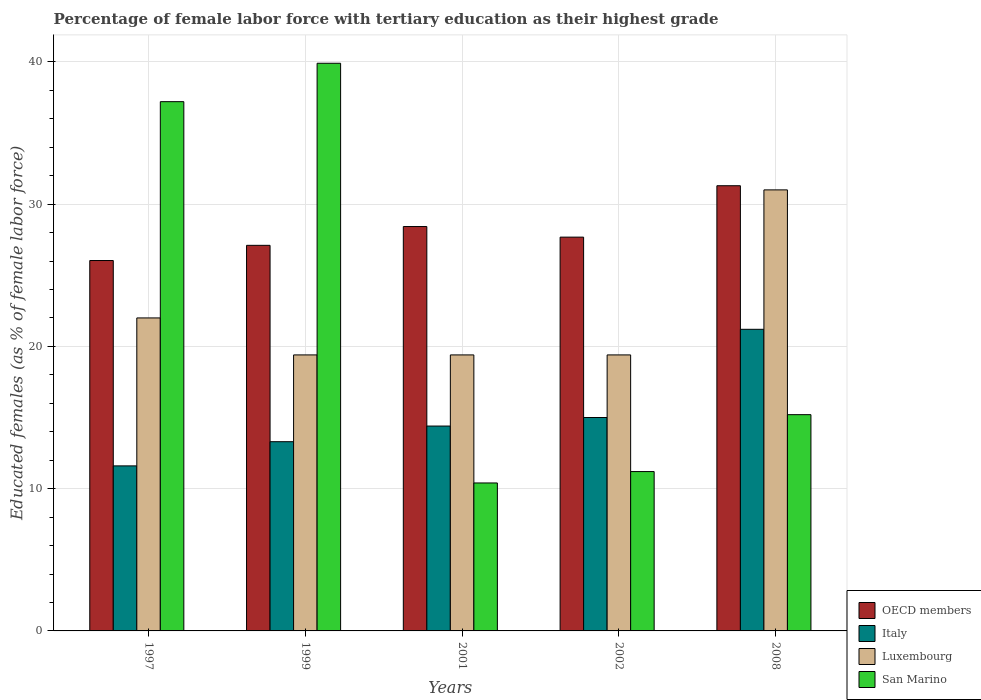How many groups of bars are there?
Provide a succinct answer. 5. Are the number of bars per tick equal to the number of legend labels?
Your answer should be very brief. Yes. Are the number of bars on each tick of the X-axis equal?
Provide a short and direct response. Yes. How many bars are there on the 4th tick from the right?
Offer a very short reply. 4. What is the label of the 5th group of bars from the left?
Offer a terse response. 2008. What is the percentage of female labor force with tertiary education in Italy in 2008?
Provide a short and direct response. 21.2. Across all years, what is the maximum percentage of female labor force with tertiary education in Italy?
Make the answer very short. 21.2. Across all years, what is the minimum percentage of female labor force with tertiary education in Italy?
Make the answer very short. 11.6. In which year was the percentage of female labor force with tertiary education in San Marino minimum?
Your answer should be compact. 2001. What is the total percentage of female labor force with tertiary education in Italy in the graph?
Keep it short and to the point. 75.5. What is the difference between the percentage of female labor force with tertiary education in OECD members in 1997 and that in 2008?
Ensure brevity in your answer.  -5.26. What is the difference between the percentage of female labor force with tertiary education in San Marino in 2002 and the percentage of female labor force with tertiary education in Luxembourg in 1999?
Make the answer very short. -8.2. What is the average percentage of female labor force with tertiary education in San Marino per year?
Your answer should be compact. 22.78. In the year 2001, what is the difference between the percentage of female labor force with tertiary education in Luxembourg and percentage of female labor force with tertiary education in OECD members?
Keep it short and to the point. -9.02. What is the ratio of the percentage of female labor force with tertiary education in OECD members in 2002 to that in 2008?
Give a very brief answer. 0.88. Is the percentage of female labor force with tertiary education in San Marino in 1997 less than that in 2001?
Provide a succinct answer. No. What is the difference between the highest and the second highest percentage of female labor force with tertiary education in OECD members?
Keep it short and to the point. 2.87. What is the difference between the highest and the lowest percentage of female labor force with tertiary education in San Marino?
Offer a very short reply. 29.5. Is the sum of the percentage of female labor force with tertiary education in Luxembourg in 2001 and 2008 greater than the maximum percentage of female labor force with tertiary education in San Marino across all years?
Your response must be concise. Yes. What does the 1st bar from the left in 2001 represents?
Offer a very short reply. OECD members. What does the 2nd bar from the right in 2001 represents?
Your answer should be very brief. Luxembourg. Is it the case that in every year, the sum of the percentage of female labor force with tertiary education in Italy and percentage of female labor force with tertiary education in San Marino is greater than the percentage of female labor force with tertiary education in Luxembourg?
Keep it short and to the point. Yes. Does the graph contain any zero values?
Provide a short and direct response. No. Does the graph contain grids?
Your response must be concise. Yes. What is the title of the graph?
Keep it short and to the point. Percentage of female labor force with tertiary education as their highest grade. Does "Ecuador" appear as one of the legend labels in the graph?
Offer a very short reply. No. What is the label or title of the Y-axis?
Provide a succinct answer. Educated females (as % of female labor force). What is the Educated females (as % of female labor force) in OECD members in 1997?
Your answer should be compact. 26.03. What is the Educated females (as % of female labor force) in Italy in 1997?
Make the answer very short. 11.6. What is the Educated females (as % of female labor force) in San Marino in 1997?
Offer a terse response. 37.2. What is the Educated females (as % of female labor force) in OECD members in 1999?
Ensure brevity in your answer.  27.1. What is the Educated females (as % of female labor force) of Italy in 1999?
Provide a short and direct response. 13.3. What is the Educated females (as % of female labor force) in Luxembourg in 1999?
Give a very brief answer. 19.4. What is the Educated females (as % of female labor force) of San Marino in 1999?
Ensure brevity in your answer.  39.9. What is the Educated females (as % of female labor force) in OECD members in 2001?
Your answer should be very brief. 28.42. What is the Educated females (as % of female labor force) of Italy in 2001?
Your answer should be compact. 14.4. What is the Educated females (as % of female labor force) of Luxembourg in 2001?
Provide a succinct answer. 19.4. What is the Educated females (as % of female labor force) of San Marino in 2001?
Offer a terse response. 10.4. What is the Educated females (as % of female labor force) in OECD members in 2002?
Provide a succinct answer. 27.68. What is the Educated females (as % of female labor force) in Luxembourg in 2002?
Provide a succinct answer. 19.4. What is the Educated females (as % of female labor force) in San Marino in 2002?
Provide a succinct answer. 11.2. What is the Educated females (as % of female labor force) in OECD members in 2008?
Provide a succinct answer. 31.29. What is the Educated females (as % of female labor force) in Italy in 2008?
Your answer should be very brief. 21.2. What is the Educated females (as % of female labor force) in Luxembourg in 2008?
Make the answer very short. 31. What is the Educated females (as % of female labor force) of San Marino in 2008?
Ensure brevity in your answer.  15.2. Across all years, what is the maximum Educated females (as % of female labor force) of OECD members?
Make the answer very short. 31.29. Across all years, what is the maximum Educated females (as % of female labor force) in Italy?
Your answer should be compact. 21.2. Across all years, what is the maximum Educated females (as % of female labor force) of San Marino?
Keep it short and to the point. 39.9. Across all years, what is the minimum Educated females (as % of female labor force) in OECD members?
Ensure brevity in your answer.  26.03. Across all years, what is the minimum Educated females (as % of female labor force) of Italy?
Make the answer very short. 11.6. Across all years, what is the minimum Educated females (as % of female labor force) in Luxembourg?
Offer a terse response. 19.4. Across all years, what is the minimum Educated females (as % of female labor force) of San Marino?
Keep it short and to the point. 10.4. What is the total Educated females (as % of female labor force) in OECD members in the graph?
Provide a short and direct response. 140.53. What is the total Educated females (as % of female labor force) in Italy in the graph?
Offer a terse response. 75.5. What is the total Educated females (as % of female labor force) of Luxembourg in the graph?
Offer a terse response. 111.2. What is the total Educated females (as % of female labor force) in San Marino in the graph?
Your answer should be compact. 113.9. What is the difference between the Educated females (as % of female labor force) of OECD members in 1997 and that in 1999?
Offer a terse response. -1.07. What is the difference between the Educated females (as % of female labor force) in Italy in 1997 and that in 1999?
Give a very brief answer. -1.7. What is the difference between the Educated females (as % of female labor force) of OECD members in 1997 and that in 2001?
Provide a short and direct response. -2.39. What is the difference between the Educated females (as % of female labor force) in Italy in 1997 and that in 2001?
Make the answer very short. -2.8. What is the difference between the Educated females (as % of female labor force) of San Marino in 1997 and that in 2001?
Provide a succinct answer. 26.8. What is the difference between the Educated females (as % of female labor force) in OECD members in 1997 and that in 2002?
Make the answer very short. -1.64. What is the difference between the Educated females (as % of female labor force) of Italy in 1997 and that in 2002?
Offer a very short reply. -3.4. What is the difference between the Educated females (as % of female labor force) of Luxembourg in 1997 and that in 2002?
Provide a succinct answer. 2.6. What is the difference between the Educated females (as % of female labor force) of OECD members in 1997 and that in 2008?
Your answer should be compact. -5.26. What is the difference between the Educated females (as % of female labor force) in Italy in 1997 and that in 2008?
Your response must be concise. -9.6. What is the difference between the Educated females (as % of female labor force) in Luxembourg in 1997 and that in 2008?
Offer a very short reply. -9. What is the difference between the Educated females (as % of female labor force) in OECD members in 1999 and that in 2001?
Ensure brevity in your answer.  -1.32. What is the difference between the Educated females (as % of female labor force) of Italy in 1999 and that in 2001?
Offer a terse response. -1.1. What is the difference between the Educated females (as % of female labor force) of Luxembourg in 1999 and that in 2001?
Ensure brevity in your answer.  0. What is the difference between the Educated females (as % of female labor force) of San Marino in 1999 and that in 2001?
Provide a short and direct response. 29.5. What is the difference between the Educated females (as % of female labor force) of OECD members in 1999 and that in 2002?
Your response must be concise. -0.58. What is the difference between the Educated females (as % of female labor force) of San Marino in 1999 and that in 2002?
Offer a very short reply. 28.7. What is the difference between the Educated females (as % of female labor force) in OECD members in 1999 and that in 2008?
Offer a very short reply. -4.19. What is the difference between the Educated females (as % of female labor force) of Italy in 1999 and that in 2008?
Give a very brief answer. -7.9. What is the difference between the Educated females (as % of female labor force) in San Marino in 1999 and that in 2008?
Give a very brief answer. 24.7. What is the difference between the Educated females (as % of female labor force) in OECD members in 2001 and that in 2002?
Provide a short and direct response. 0.74. What is the difference between the Educated females (as % of female labor force) of OECD members in 2001 and that in 2008?
Your answer should be very brief. -2.87. What is the difference between the Educated females (as % of female labor force) of OECD members in 2002 and that in 2008?
Offer a terse response. -3.61. What is the difference between the Educated females (as % of female labor force) of Luxembourg in 2002 and that in 2008?
Your response must be concise. -11.6. What is the difference between the Educated females (as % of female labor force) in OECD members in 1997 and the Educated females (as % of female labor force) in Italy in 1999?
Keep it short and to the point. 12.73. What is the difference between the Educated females (as % of female labor force) in OECD members in 1997 and the Educated females (as % of female labor force) in Luxembourg in 1999?
Provide a short and direct response. 6.63. What is the difference between the Educated females (as % of female labor force) in OECD members in 1997 and the Educated females (as % of female labor force) in San Marino in 1999?
Your answer should be compact. -13.87. What is the difference between the Educated females (as % of female labor force) in Italy in 1997 and the Educated females (as % of female labor force) in Luxembourg in 1999?
Provide a short and direct response. -7.8. What is the difference between the Educated females (as % of female labor force) of Italy in 1997 and the Educated females (as % of female labor force) of San Marino in 1999?
Provide a short and direct response. -28.3. What is the difference between the Educated females (as % of female labor force) of Luxembourg in 1997 and the Educated females (as % of female labor force) of San Marino in 1999?
Offer a very short reply. -17.9. What is the difference between the Educated females (as % of female labor force) of OECD members in 1997 and the Educated females (as % of female labor force) of Italy in 2001?
Give a very brief answer. 11.63. What is the difference between the Educated females (as % of female labor force) in OECD members in 1997 and the Educated females (as % of female labor force) in Luxembourg in 2001?
Make the answer very short. 6.63. What is the difference between the Educated females (as % of female labor force) of OECD members in 1997 and the Educated females (as % of female labor force) of San Marino in 2001?
Give a very brief answer. 15.63. What is the difference between the Educated females (as % of female labor force) of Italy in 1997 and the Educated females (as % of female labor force) of Luxembourg in 2001?
Your response must be concise. -7.8. What is the difference between the Educated females (as % of female labor force) in Italy in 1997 and the Educated females (as % of female labor force) in San Marino in 2001?
Offer a very short reply. 1.2. What is the difference between the Educated females (as % of female labor force) in OECD members in 1997 and the Educated females (as % of female labor force) in Italy in 2002?
Give a very brief answer. 11.03. What is the difference between the Educated females (as % of female labor force) in OECD members in 1997 and the Educated females (as % of female labor force) in Luxembourg in 2002?
Provide a succinct answer. 6.63. What is the difference between the Educated females (as % of female labor force) of OECD members in 1997 and the Educated females (as % of female labor force) of San Marino in 2002?
Your response must be concise. 14.83. What is the difference between the Educated females (as % of female labor force) of Italy in 1997 and the Educated females (as % of female labor force) of San Marino in 2002?
Your response must be concise. 0.4. What is the difference between the Educated females (as % of female labor force) in Luxembourg in 1997 and the Educated females (as % of female labor force) in San Marino in 2002?
Offer a very short reply. 10.8. What is the difference between the Educated females (as % of female labor force) of OECD members in 1997 and the Educated females (as % of female labor force) of Italy in 2008?
Keep it short and to the point. 4.83. What is the difference between the Educated females (as % of female labor force) in OECD members in 1997 and the Educated females (as % of female labor force) in Luxembourg in 2008?
Give a very brief answer. -4.97. What is the difference between the Educated females (as % of female labor force) in OECD members in 1997 and the Educated females (as % of female labor force) in San Marino in 2008?
Your answer should be compact. 10.83. What is the difference between the Educated females (as % of female labor force) of Italy in 1997 and the Educated females (as % of female labor force) of Luxembourg in 2008?
Keep it short and to the point. -19.4. What is the difference between the Educated females (as % of female labor force) in Italy in 1997 and the Educated females (as % of female labor force) in San Marino in 2008?
Offer a terse response. -3.6. What is the difference between the Educated females (as % of female labor force) of Luxembourg in 1997 and the Educated females (as % of female labor force) of San Marino in 2008?
Your response must be concise. 6.8. What is the difference between the Educated females (as % of female labor force) of OECD members in 1999 and the Educated females (as % of female labor force) of Italy in 2001?
Offer a terse response. 12.7. What is the difference between the Educated females (as % of female labor force) of OECD members in 1999 and the Educated females (as % of female labor force) of Luxembourg in 2001?
Give a very brief answer. 7.7. What is the difference between the Educated females (as % of female labor force) of OECD members in 1999 and the Educated females (as % of female labor force) of San Marino in 2001?
Ensure brevity in your answer.  16.7. What is the difference between the Educated females (as % of female labor force) of Luxembourg in 1999 and the Educated females (as % of female labor force) of San Marino in 2001?
Your answer should be very brief. 9. What is the difference between the Educated females (as % of female labor force) of OECD members in 1999 and the Educated females (as % of female labor force) of Italy in 2002?
Provide a short and direct response. 12.1. What is the difference between the Educated females (as % of female labor force) of OECD members in 1999 and the Educated females (as % of female labor force) of Luxembourg in 2002?
Keep it short and to the point. 7.7. What is the difference between the Educated females (as % of female labor force) in OECD members in 1999 and the Educated females (as % of female labor force) in San Marino in 2002?
Your answer should be very brief. 15.9. What is the difference between the Educated females (as % of female labor force) in Italy in 1999 and the Educated females (as % of female labor force) in Luxembourg in 2002?
Provide a short and direct response. -6.1. What is the difference between the Educated females (as % of female labor force) in Italy in 1999 and the Educated females (as % of female labor force) in San Marino in 2002?
Offer a very short reply. 2.1. What is the difference between the Educated females (as % of female labor force) in Luxembourg in 1999 and the Educated females (as % of female labor force) in San Marino in 2002?
Your answer should be compact. 8.2. What is the difference between the Educated females (as % of female labor force) of OECD members in 1999 and the Educated females (as % of female labor force) of Italy in 2008?
Offer a very short reply. 5.9. What is the difference between the Educated females (as % of female labor force) of OECD members in 1999 and the Educated females (as % of female labor force) of Luxembourg in 2008?
Ensure brevity in your answer.  -3.9. What is the difference between the Educated females (as % of female labor force) of OECD members in 1999 and the Educated females (as % of female labor force) of San Marino in 2008?
Your answer should be compact. 11.9. What is the difference between the Educated females (as % of female labor force) of Italy in 1999 and the Educated females (as % of female labor force) of Luxembourg in 2008?
Keep it short and to the point. -17.7. What is the difference between the Educated females (as % of female labor force) of Italy in 1999 and the Educated females (as % of female labor force) of San Marino in 2008?
Give a very brief answer. -1.9. What is the difference between the Educated females (as % of female labor force) of OECD members in 2001 and the Educated females (as % of female labor force) of Italy in 2002?
Ensure brevity in your answer.  13.42. What is the difference between the Educated females (as % of female labor force) in OECD members in 2001 and the Educated females (as % of female labor force) in Luxembourg in 2002?
Your response must be concise. 9.02. What is the difference between the Educated females (as % of female labor force) of OECD members in 2001 and the Educated females (as % of female labor force) of San Marino in 2002?
Your answer should be very brief. 17.22. What is the difference between the Educated females (as % of female labor force) in Luxembourg in 2001 and the Educated females (as % of female labor force) in San Marino in 2002?
Give a very brief answer. 8.2. What is the difference between the Educated females (as % of female labor force) of OECD members in 2001 and the Educated females (as % of female labor force) of Italy in 2008?
Offer a terse response. 7.22. What is the difference between the Educated females (as % of female labor force) in OECD members in 2001 and the Educated females (as % of female labor force) in Luxembourg in 2008?
Your response must be concise. -2.58. What is the difference between the Educated females (as % of female labor force) in OECD members in 2001 and the Educated females (as % of female labor force) in San Marino in 2008?
Make the answer very short. 13.22. What is the difference between the Educated females (as % of female labor force) in Italy in 2001 and the Educated females (as % of female labor force) in Luxembourg in 2008?
Make the answer very short. -16.6. What is the difference between the Educated females (as % of female labor force) in Italy in 2001 and the Educated females (as % of female labor force) in San Marino in 2008?
Your response must be concise. -0.8. What is the difference between the Educated females (as % of female labor force) in OECD members in 2002 and the Educated females (as % of female labor force) in Italy in 2008?
Your answer should be very brief. 6.48. What is the difference between the Educated females (as % of female labor force) of OECD members in 2002 and the Educated females (as % of female labor force) of Luxembourg in 2008?
Make the answer very short. -3.32. What is the difference between the Educated females (as % of female labor force) of OECD members in 2002 and the Educated females (as % of female labor force) of San Marino in 2008?
Your answer should be very brief. 12.48. What is the average Educated females (as % of female labor force) in OECD members per year?
Ensure brevity in your answer.  28.11. What is the average Educated females (as % of female labor force) in Luxembourg per year?
Ensure brevity in your answer.  22.24. What is the average Educated females (as % of female labor force) in San Marino per year?
Your answer should be compact. 22.78. In the year 1997, what is the difference between the Educated females (as % of female labor force) in OECD members and Educated females (as % of female labor force) in Italy?
Offer a very short reply. 14.43. In the year 1997, what is the difference between the Educated females (as % of female labor force) of OECD members and Educated females (as % of female labor force) of Luxembourg?
Your answer should be compact. 4.03. In the year 1997, what is the difference between the Educated females (as % of female labor force) of OECD members and Educated females (as % of female labor force) of San Marino?
Ensure brevity in your answer.  -11.17. In the year 1997, what is the difference between the Educated females (as % of female labor force) of Italy and Educated females (as % of female labor force) of Luxembourg?
Provide a succinct answer. -10.4. In the year 1997, what is the difference between the Educated females (as % of female labor force) of Italy and Educated females (as % of female labor force) of San Marino?
Offer a terse response. -25.6. In the year 1997, what is the difference between the Educated females (as % of female labor force) of Luxembourg and Educated females (as % of female labor force) of San Marino?
Provide a succinct answer. -15.2. In the year 1999, what is the difference between the Educated females (as % of female labor force) of OECD members and Educated females (as % of female labor force) of Italy?
Your answer should be very brief. 13.8. In the year 1999, what is the difference between the Educated females (as % of female labor force) in OECD members and Educated females (as % of female labor force) in Luxembourg?
Your answer should be very brief. 7.7. In the year 1999, what is the difference between the Educated females (as % of female labor force) of OECD members and Educated females (as % of female labor force) of San Marino?
Provide a short and direct response. -12.8. In the year 1999, what is the difference between the Educated females (as % of female labor force) of Italy and Educated females (as % of female labor force) of San Marino?
Ensure brevity in your answer.  -26.6. In the year 1999, what is the difference between the Educated females (as % of female labor force) of Luxembourg and Educated females (as % of female labor force) of San Marino?
Offer a terse response. -20.5. In the year 2001, what is the difference between the Educated females (as % of female labor force) in OECD members and Educated females (as % of female labor force) in Italy?
Your answer should be compact. 14.02. In the year 2001, what is the difference between the Educated females (as % of female labor force) of OECD members and Educated females (as % of female labor force) of Luxembourg?
Your answer should be very brief. 9.02. In the year 2001, what is the difference between the Educated females (as % of female labor force) in OECD members and Educated females (as % of female labor force) in San Marino?
Your answer should be compact. 18.02. In the year 2001, what is the difference between the Educated females (as % of female labor force) in Italy and Educated females (as % of female labor force) in San Marino?
Provide a short and direct response. 4. In the year 2001, what is the difference between the Educated females (as % of female labor force) in Luxembourg and Educated females (as % of female labor force) in San Marino?
Provide a short and direct response. 9. In the year 2002, what is the difference between the Educated females (as % of female labor force) of OECD members and Educated females (as % of female labor force) of Italy?
Ensure brevity in your answer.  12.68. In the year 2002, what is the difference between the Educated females (as % of female labor force) of OECD members and Educated females (as % of female labor force) of Luxembourg?
Provide a short and direct response. 8.28. In the year 2002, what is the difference between the Educated females (as % of female labor force) in OECD members and Educated females (as % of female labor force) in San Marino?
Your answer should be very brief. 16.48. In the year 2002, what is the difference between the Educated females (as % of female labor force) in Italy and Educated females (as % of female labor force) in Luxembourg?
Make the answer very short. -4.4. In the year 2002, what is the difference between the Educated females (as % of female labor force) of Italy and Educated females (as % of female labor force) of San Marino?
Make the answer very short. 3.8. In the year 2008, what is the difference between the Educated females (as % of female labor force) of OECD members and Educated females (as % of female labor force) of Italy?
Provide a succinct answer. 10.09. In the year 2008, what is the difference between the Educated females (as % of female labor force) in OECD members and Educated females (as % of female labor force) in Luxembourg?
Your response must be concise. 0.29. In the year 2008, what is the difference between the Educated females (as % of female labor force) of OECD members and Educated females (as % of female labor force) of San Marino?
Provide a short and direct response. 16.09. In the year 2008, what is the difference between the Educated females (as % of female labor force) in Italy and Educated females (as % of female labor force) in Luxembourg?
Offer a terse response. -9.8. In the year 2008, what is the difference between the Educated females (as % of female labor force) of Luxembourg and Educated females (as % of female labor force) of San Marino?
Your answer should be compact. 15.8. What is the ratio of the Educated females (as % of female labor force) in OECD members in 1997 to that in 1999?
Give a very brief answer. 0.96. What is the ratio of the Educated females (as % of female labor force) in Italy in 1997 to that in 1999?
Provide a succinct answer. 0.87. What is the ratio of the Educated females (as % of female labor force) in Luxembourg in 1997 to that in 1999?
Offer a terse response. 1.13. What is the ratio of the Educated females (as % of female labor force) of San Marino in 1997 to that in 1999?
Provide a succinct answer. 0.93. What is the ratio of the Educated females (as % of female labor force) in OECD members in 1997 to that in 2001?
Make the answer very short. 0.92. What is the ratio of the Educated females (as % of female labor force) in Italy in 1997 to that in 2001?
Your answer should be very brief. 0.81. What is the ratio of the Educated females (as % of female labor force) in Luxembourg in 1997 to that in 2001?
Provide a succinct answer. 1.13. What is the ratio of the Educated females (as % of female labor force) in San Marino in 1997 to that in 2001?
Your answer should be compact. 3.58. What is the ratio of the Educated females (as % of female labor force) in OECD members in 1997 to that in 2002?
Your answer should be very brief. 0.94. What is the ratio of the Educated females (as % of female labor force) of Italy in 1997 to that in 2002?
Your response must be concise. 0.77. What is the ratio of the Educated females (as % of female labor force) in Luxembourg in 1997 to that in 2002?
Make the answer very short. 1.13. What is the ratio of the Educated females (as % of female labor force) of San Marino in 1997 to that in 2002?
Give a very brief answer. 3.32. What is the ratio of the Educated females (as % of female labor force) of OECD members in 1997 to that in 2008?
Make the answer very short. 0.83. What is the ratio of the Educated females (as % of female labor force) in Italy in 1997 to that in 2008?
Ensure brevity in your answer.  0.55. What is the ratio of the Educated females (as % of female labor force) of Luxembourg in 1997 to that in 2008?
Your answer should be very brief. 0.71. What is the ratio of the Educated females (as % of female labor force) of San Marino in 1997 to that in 2008?
Provide a short and direct response. 2.45. What is the ratio of the Educated females (as % of female labor force) of OECD members in 1999 to that in 2001?
Your answer should be compact. 0.95. What is the ratio of the Educated females (as % of female labor force) in Italy in 1999 to that in 2001?
Your response must be concise. 0.92. What is the ratio of the Educated females (as % of female labor force) in Luxembourg in 1999 to that in 2001?
Your answer should be very brief. 1. What is the ratio of the Educated females (as % of female labor force) of San Marino in 1999 to that in 2001?
Make the answer very short. 3.84. What is the ratio of the Educated females (as % of female labor force) of OECD members in 1999 to that in 2002?
Provide a succinct answer. 0.98. What is the ratio of the Educated females (as % of female labor force) in Italy in 1999 to that in 2002?
Offer a terse response. 0.89. What is the ratio of the Educated females (as % of female labor force) in San Marino in 1999 to that in 2002?
Offer a very short reply. 3.56. What is the ratio of the Educated females (as % of female labor force) of OECD members in 1999 to that in 2008?
Provide a short and direct response. 0.87. What is the ratio of the Educated females (as % of female labor force) of Italy in 1999 to that in 2008?
Keep it short and to the point. 0.63. What is the ratio of the Educated females (as % of female labor force) of Luxembourg in 1999 to that in 2008?
Offer a terse response. 0.63. What is the ratio of the Educated females (as % of female labor force) in San Marino in 1999 to that in 2008?
Provide a short and direct response. 2.62. What is the ratio of the Educated females (as % of female labor force) in OECD members in 2001 to that in 2002?
Provide a short and direct response. 1.03. What is the ratio of the Educated females (as % of female labor force) in Italy in 2001 to that in 2002?
Make the answer very short. 0.96. What is the ratio of the Educated females (as % of female labor force) of Luxembourg in 2001 to that in 2002?
Offer a very short reply. 1. What is the ratio of the Educated females (as % of female labor force) of San Marino in 2001 to that in 2002?
Make the answer very short. 0.93. What is the ratio of the Educated females (as % of female labor force) of OECD members in 2001 to that in 2008?
Your response must be concise. 0.91. What is the ratio of the Educated females (as % of female labor force) of Italy in 2001 to that in 2008?
Your answer should be compact. 0.68. What is the ratio of the Educated females (as % of female labor force) of Luxembourg in 2001 to that in 2008?
Offer a very short reply. 0.63. What is the ratio of the Educated females (as % of female labor force) in San Marino in 2001 to that in 2008?
Provide a short and direct response. 0.68. What is the ratio of the Educated females (as % of female labor force) of OECD members in 2002 to that in 2008?
Ensure brevity in your answer.  0.88. What is the ratio of the Educated females (as % of female labor force) in Italy in 2002 to that in 2008?
Your answer should be compact. 0.71. What is the ratio of the Educated females (as % of female labor force) in Luxembourg in 2002 to that in 2008?
Ensure brevity in your answer.  0.63. What is the ratio of the Educated females (as % of female labor force) in San Marino in 2002 to that in 2008?
Offer a very short reply. 0.74. What is the difference between the highest and the second highest Educated females (as % of female labor force) in OECD members?
Your answer should be compact. 2.87. What is the difference between the highest and the second highest Educated females (as % of female labor force) in Italy?
Give a very brief answer. 6.2. What is the difference between the highest and the second highest Educated females (as % of female labor force) of Luxembourg?
Your answer should be compact. 9. What is the difference between the highest and the second highest Educated females (as % of female labor force) in San Marino?
Provide a succinct answer. 2.7. What is the difference between the highest and the lowest Educated females (as % of female labor force) of OECD members?
Provide a short and direct response. 5.26. What is the difference between the highest and the lowest Educated females (as % of female labor force) of Luxembourg?
Provide a succinct answer. 11.6. What is the difference between the highest and the lowest Educated females (as % of female labor force) in San Marino?
Your answer should be compact. 29.5. 